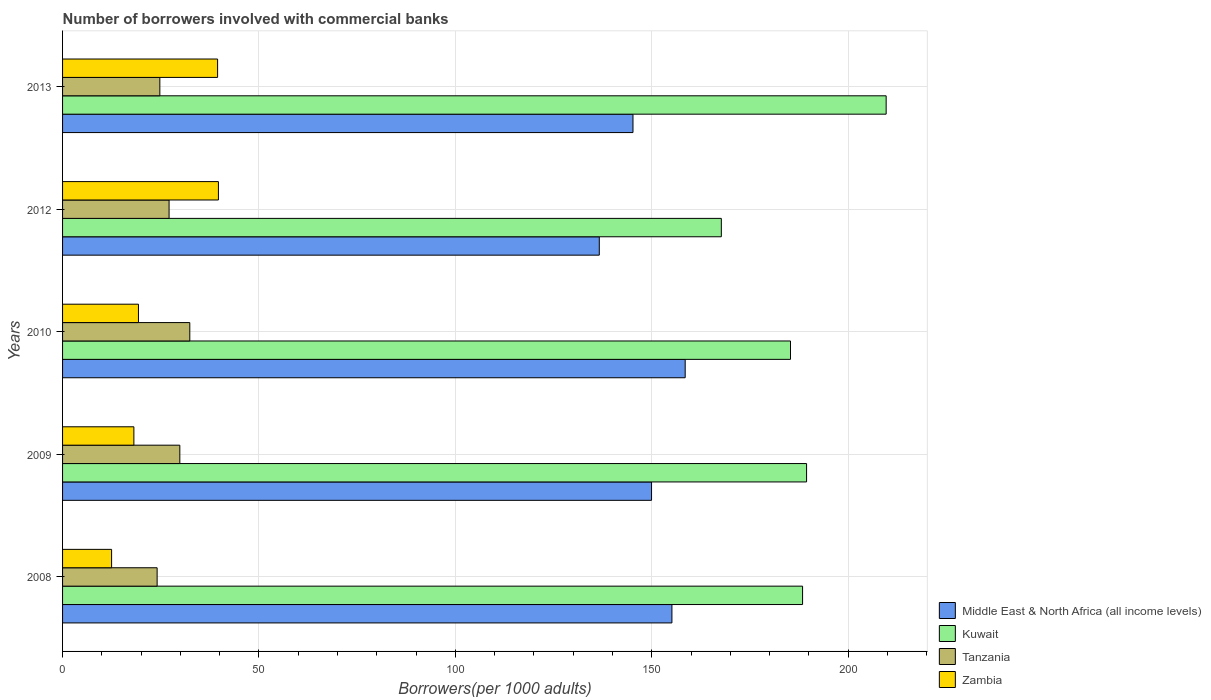How many different coloured bars are there?
Offer a terse response. 4. Are the number of bars per tick equal to the number of legend labels?
Your answer should be compact. Yes. How many bars are there on the 3rd tick from the top?
Offer a very short reply. 4. How many bars are there on the 3rd tick from the bottom?
Give a very brief answer. 4. What is the label of the 1st group of bars from the top?
Make the answer very short. 2013. What is the number of borrowers involved with commercial banks in Kuwait in 2008?
Give a very brief answer. 188.4. Across all years, what is the maximum number of borrowers involved with commercial banks in Middle East & North Africa (all income levels)?
Your response must be concise. 158.51. Across all years, what is the minimum number of borrowers involved with commercial banks in Kuwait?
Your answer should be very brief. 167.71. In which year was the number of borrowers involved with commercial banks in Zambia maximum?
Give a very brief answer. 2012. What is the total number of borrowers involved with commercial banks in Zambia in the graph?
Your response must be concise. 129.1. What is the difference between the number of borrowers involved with commercial banks in Tanzania in 2009 and that in 2012?
Your answer should be compact. 2.74. What is the difference between the number of borrowers involved with commercial banks in Middle East & North Africa (all income levels) in 2010 and the number of borrowers involved with commercial banks in Zambia in 2009?
Provide a short and direct response. 140.36. What is the average number of borrowers involved with commercial banks in Kuwait per year?
Give a very brief answer. 188.1. In the year 2009, what is the difference between the number of borrowers involved with commercial banks in Kuwait and number of borrowers involved with commercial banks in Zambia?
Your answer should be compact. 171.26. What is the ratio of the number of borrowers involved with commercial banks in Kuwait in 2009 to that in 2012?
Offer a very short reply. 1.13. Is the number of borrowers involved with commercial banks in Middle East & North Africa (all income levels) in 2010 less than that in 2012?
Your answer should be very brief. No. What is the difference between the highest and the second highest number of borrowers involved with commercial banks in Kuwait?
Provide a short and direct response. 20.26. What is the difference between the highest and the lowest number of borrowers involved with commercial banks in Middle East & North Africa (all income levels)?
Offer a very short reply. 21.87. What does the 1st bar from the top in 2009 represents?
Your answer should be compact. Zambia. What does the 1st bar from the bottom in 2008 represents?
Provide a short and direct response. Middle East & North Africa (all income levels). Is it the case that in every year, the sum of the number of borrowers involved with commercial banks in Tanzania and number of borrowers involved with commercial banks in Middle East & North Africa (all income levels) is greater than the number of borrowers involved with commercial banks in Zambia?
Keep it short and to the point. Yes. How many bars are there?
Offer a terse response. 20. What is the difference between two consecutive major ticks on the X-axis?
Provide a short and direct response. 50. How many legend labels are there?
Offer a terse response. 4. How are the legend labels stacked?
Offer a very short reply. Vertical. What is the title of the graph?
Offer a very short reply. Number of borrowers involved with commercial banks. Does "Somalia" appear as one of the legend labels in the graph?
Offer a terse response. No. What is the label or title of the X-axis?
Provide a short and direct response. Borrowers(per 1000 adults). What is the Borrowers(per 1000 adults) in Middle East & North Africa (all income levels) in 2008?
Offer a very short reply. 155.14. What is the Borrowers(per 1000 adults) in Kuwait in 2008?
Your response must be concise. 188.4. What is the Borrowers(per 1000 adults) in Tanzania in 2008?
Keep it short and to the point. 24.08. What is the Borrowers(per 1000 adults) in Zambia in 2008?
Offer a terse response. 12.48. What is the Borrowers(per 1000 adults) of Middle East & North Africa (all income levels) in 2009?
Your answer should be compact. 149.95. What is the Borrowers(per 1000 adults) in Kuwait in 2009?
Your answer should be very brief. 189.42. What is the Borrowers(per 1000 adults) of Tanzania in 2009?
Your answer should be compact. 29.86. What is the Borrowers(per 1000 adults) of Zambia in 2009?
Your response must be concise. 18.15. What is the Borrowers(per 1000 adults) of Middle East & North Africa (all income levels) in 2010?
Your response must be concise. 158.51. What is the Borrowers(per 1000 adults) in Kuwait in 2010?
Offer a very short reply. 185.32. What is the Borrowers(per 1000 adults) of Tanzania in 2010?
Ensure brevity in your answer.  32.39. What is the Borrowers(per 1000 adults) of Zambia in 2010?
Ensure brevity in your answer.  19.32. What is the Borrowers(per 1000 adults) in Middle East & North Africa (all income levels) in 2012?
Ensure brevity in your answer.  136.65. What is the Borrowers(per 1000 adults) in Kuwait in 2012?
Provide a short and direct response. 167.71. What is the Borrowers(per 1000 adults) of Tanzania in 2012?
Your answer should be compact. 27.12. What is the Borrowers(per 1000 adults) in Zambia in 2012?
Give a very brief answer. 39.68. What is the Borrowers(per 1000 adults) of Middle East & North Africa (all income levels) in 2013?
Your response must be concise. 145.22. What is the Borrowers(per 1000 adults) of Kuwait in 2013?
Ensure brevity in your answer.  209.68. What is the Borrowers(per 1000 adults) of Tanzania in 2013?
Your response must be concise. 24.77. What is the Borrowers(per 1000 adults) of Zambia in 2013?
Provide a short and direct response. 39.47. Across all years, what is the maximum Borrowers(per 1000 adults) in Middle East & North Africa (all income levels)?
Your answer should be very brief. 158.51. Across all years, what is the maximum Borrowers(per 1000 adults) in Kuwait?
Give a very brief answer. 209.68. Across all years, what is the maximum Borrowers(per 1000 adults) of Tanzania?
Ensure brevity in your answer.  32.39. Across all years, what is the maximum Borrowers(per 1000 adults) of Zambia?
Your answer should be compact. 39.68. Across all years, what is the minimum Borrowers(per 1000 adults) of Middle East & North Africa (all income levels)?
Provide a short and direct response. 136.65. Across all years, what is the minimum Borrowers(per 1000 adults) of Kuwait?
Make the answer very short. 167.71. Across all years, what is the minimum Borrowers(per 1000 adults) of Tanzania?
Offer a very short reply. 24.08. Across all years, what is the minimum Borrowers(per 1000 adults) in Zambia?
Your response must be concise. 12.48. What is the total Borrowers(per 1000 adults) of Middle East & North Africa (all income levels) in the graph?
Your response must be concise. 745.47. What is the total Borrowers(per 1000 adults) in Kuwait in the graph?
Give a very brief answer. 940.52. What is the total Borrowers(per 1000 adults) in Tanzania in the graph?
Keep it short and to the point. 138.2. What is the total Borrowers(per 1000 adults) of Zambia in the graph?
Your answer should be compact. 129.1. What is the difference between the Borrowers(per 1000 adults) of Middle East & North Africa (all income levels) in 2008 and that in 2009?
Keep it short and to the point. 5.19. What is the difference between the Borrowers(per 1000 adults) in Kuwait in 2008 and that in 2009?
Ensure brevity in your answer.  -1.02. What is the difference between the Borrowers(per 1000 adults) of Tanzania in 2008 and that in 2009?
Your answer should be compact. -5.78. What is the difference between the Borrowers(per 1000 adults) of Zambia in 2008 and that in 2009?
Give a very brief answer. -5.67. What is the difference between the Borrowers(per 1000 adults) of Middle East & North Africa (all income levels) in 2008 and that in 2010?
Your answer should be compact. -3.38. What is the difference between the Borrowers(per 1000 adults) of Kuwait in 2008 and that in 2010?
Make the answer very short. 3.08. What is the difference between the Borrowers(per 1000 adults) of Tanzania in 2008 and that in 2010?
Give a very brief answer. -8.32. What is the difference between the Borrowers(per 1000 adults) of Zambia in 2008 and that in 2010?
Provide a succinct answer. -6.84. What is the difference between the Borrowers(per 1000 adults) of Middle East & North Africa (all income levels) in 2008 and that in 2012?
Ensure brevity in your answer.  18.49. What is the difference between the Borrowers(per 1000 adults) in Kuwait in 2008 and that in 2012?
Provide a succinct answer. 20.68. What is the difference between the Borrowers(per 1000 adults) in Tanzania in 2008 and that in 2012?
Provide a short and direct response. -3.04. What is the difference between the Borrowers(per 1000 adults) of Zambia in 2008 and that in 2012?
Your answer should be very brief. -27.2. What is the difference between the Borrowers(per 1000 adults) of Middle East & North Africa (all income levels) in 2008 and that in 2013?
Your answer should be compact. 9.91. What is the difference between the Borrowers(per 1000 adults) in Kuwait in 2008 and that in 2013?
Provide a short and direct response. -21.28. What is the difference between the Borrowers(per 1000 adults) of Tanzania in 2008 and that in 2013?
Your answer should be compact. -0.69. What is the difference between the Borrowers(per 1000 adults) in Zambia in 2008 and that in 2013?
Your answer should be compact. -26.98. What is the difference between the Borrowers(per 1000 adults) of Middle East & North Africa (all income levels) in 2009 and that in 2010?
Ensure brevity in your answer.  -8.56. What is the difference between the Borrowers(per 1000 adults) of Kuwait in 2009 and that in 2010?
Your answer should be compact. 4.09. What is the difference between the Borrowers(per 1000 adults) of Tanzania in 2009 and that in 2010?
Provide a short and direct response. -2.54. What is the difference between the Borrowers(per 1000 adults) of Zambia in 2009 and that in 2010?
Your response must be concise. -1.17. What is the difference between the Borrowers(per 1000 adults) in Middle East & North Africa (all income levels) in 2009 and that in 2012?
Provide a succinct answer. 13.3. What is the difference between the Borrowers(per 1000 adults) of Kuwait in 2009 and that in 2012?
Offer a terse response. 21.7. What is the difference between the Borrowers(per 1000 adults) in Tanzania in 2009 and that in 2012?
Your answer should be compact. 2.74. What is the difference between the Borrowers(per 1000 adults) of Zambia in 2009 and that in 2012?
Make the answer very short. -21.52. What is the difference between the Borrowers(per 1000 adults) of Middle East & North Africa (all income levels) in 2009 and that in 2013?
Your answer should be compact. 4.73. What is the difference between the Borrowers(per 1000 adults) of Kuwait in 2009 and that in 2013?
Provide a succinct answer. -20.26. What is the difference between the Borrowers(per 1000 adults) in Tanzania in 2009 and that in 2013?
Make the answer very short. 5.09. What is the difference between the Borrowers(per 1000 adults) of Zambia in 2009 and that in 2013?
Make the answer very short. -21.31. What is the difference between the Borrowers(per 1000 adults) in Middle East & North Africa (all income levels) in 2010 and that in 2012?
Keep it short and to the point. 21.87. What is the difference between the Borrowers(per 1000 adults) of Kuwait in 2010 and that in 2012?
Your response must be concise. 17.61. What is the difference between the Borrowers(per 1000 adults) in Tanzania in 2010 and that in 2012?
Make the answer very short. 5.28. What is the difference between the Borrowers(per 1000 adults) in Zambia in 2010 and that in 2012?
Ensure brevity in your answer.  -20.36. What is the difference between the Borrowers(per 1000 adults) in Middle East & North Africa (all income levels) in 2010 and that in 2013?
Ensure brevity in your answer.  13.29. What is the difference between the Borrowers(per 1000 adults) of Kuwait in 2010 and that in 2013?
Ensure brevity in your answer.  -24.35. What is the difference between the Borrowers(per 1000 adults) in Tanzania in 2010 and that in 2013?
Offer a very short reply. 7.63. What is the difference between the Borrowers(per 1000 adults) of Zambia in 2010 and that in 2013?
Your answer should be very brief. -20.14. What is the difference between the Borrowers(per 1000 adults) of Middle East & North Africa (all income levels) in 2012 and that in 2013?
Make the answer very short. -8.58. What is the difference between the Borrowers(per 1000 adults) in Kuwait in 2012 and that in 2013?
Your answer should be compact. -41.96. What is the difference between the Borrowers(per 1000 adults) of Tanzania in 2012 and that in 2013?
Give a very brief answer. 2.35. What is the difference between the Borrowers(per 1000 adults) in Zambia in 2012 and that in 2013?
Your answer should be very brief. 0.21. What is the difference between the Borrowers(per 1000 adults) of Middle East & North Africa (all income levels) in 2008 and the Borrowers(per 1000 adults) of Kuwait in 2009?
Your response must be concise. -34.28. What is the difference between the Borrowers(per 1000 adults) in Middle East & North Africa (all income levels) in 2008 and the Borrowers(per 1000 adults) in Tanzania in 2009?
Ensure brevity in your answer.  125.28. What is the difference between the Borrowers(per 1000 adults) of Middle East & North Africa (all income levels) in 2008 and the Borrowers(per 1000 adults) of Zambia in 2009?
Keep it short and to the point. 136.98. What is the difference between the Borrowers(per 1000 adults) in Kuwait in 2008 and the Borrowers(per 1000 adults) in Tanzania in 2009?
Keep it short and to the point. 158.54. What is the difference between the Borrowers(per 1000 adults) of Kuwait in 2008 and the Borrowers(per 1000 adults) of Zambia in 2009?
Offer a terse response. 170.24. What is the difference between the Borrowers(per 1000 adults) in Tanzania in 2008 and the Borrowers(per 1000 adults) in Zambia in 2009?
Keep it short and to the point. 5.92. What is the difference between the Borrowers(per 1000 adults) in Middle East & North Africa (all income levels) in 2008 and the Borrowers(per 1000 adults) in Kuwait in 2010?
Provide a short and direct response. -30.19. What is the difference between the Borrowers(per 1000 adults) of Middle East & North Africa (all income levels) in 2008 and the Borrowers(per 1000 adults) of Tanzania in 2010?
Your response must be concise. 122.74. What is the difference between the Borrowers(per 1000 adults) of Middle East & North Africa (all income levels) in 2008 and the Borrowers(per 1000 adults) of Zambia in 2010?
Offer a terse response. 135.81. What is the difference between the Borrowers(per 1000 adults) of Kuwait in 2008 and the Borrowers(per 1000 adults) of Tanzania in 2010?
Provide a succinct answer. 156.01. What is the difference between the Borrowers(per 1000 adults) in Kuwait in 2008 and the Borrowers(per 1000 adults) in Zambia in 2010?
Your answer should be compact. 169.08. What is the difference between the Borrowers(per 1000 adults) of Tanzania in 2008 and the Borrowers(per 1000 adults) of Zambia in 2010?
Ensure brevity in your answer.  4.75. What is the difference between the Borrowers(per 1000 adults) of Middle East & North Africa (all income levels) in 2008 and the Borrowers(per 1000 adults) of Kuwait in 2012?
Offer a terse response. -12.58. What is the difference between the Borrowers(per 1000 adults) in Middle East & North Africa (all income levels) in 2008 and the Borrowers(per 1000 adults) in Tanzania in 2012?
Provide a succinct answer. 128.02. What is the difference between the Borrowers(per 1000 adults) of Middle East & North Africa (all income levels) in 2008 and the Borrowers(per 1000 adults) of Zambia in 2012?
Provide a short and direct response. 115.46. What is the difference between the Borrowers(per 1000 adults) of Kuwait in 2008 and the Borrowers(per 1000 adults) of Tanzania in 2012?
Your answer should be compact. 161.28. What is the difference between the Borrowers(per 1000 adults) of Kuwait in 2008 and the Borrowers(per 1000 adults) of Zambia in 2012?
Offer a very short reply. 148.72. What is the difference between the Borrowers(per 1000 adults) of Tanzania in 2008 and the Borrowers(per 1000 adults) of Zambia in 2012?
Ensure brevity in your answer.  -15.6. What is the difference between the Borrowers(per 1000 adults) in Middle East & North Africa (all income levels) in 2008 and the Borrowers(per 1000 adults) in Kuwait in 2013?
Make the answer very short. -54.54. What is the difference between the Borrowers(per 1000 adults) of Middle East & North Africa (all income levels) in 2008 and the Borrowers(per 1000 adults) of Tanzania in 2013?
Your answer should be very brief. 130.37. What is the difference between the Borrowers(per 1000 adults) of Middle East & North Africa (all income levels) in 2008 and the Borrowers(per 1000 adults) of Zambia in 2013?
Offer a terse response. 115.67. What is the difference between the Borrowers(per 1000 adults) in Kuwait in 2008 and the Borrowers(per 1000 adults) in Tanzania in 2013?
Offer a terse response. 163.63. What is the difference between the Borrowers(per 1000 adults) in Kuwait in 2008 and the Borrowers(per 1000 adults) in Zambia in 2013?
Your response must be concise. 148.93. What is the difference between the Borrowers(per 1000 adults) in Tanzania in 2008 and the Borrowers(per 1000 adults) in Zambia in 2013?
Your response must be concise. -15.39. What is the difference between the Borrowers(per 1000 adults) of Middle East & North Africa (all income levels) in 2009 and the Borrowers(per 1000 adults) of Kuwait in 2010?
Give a very brief answer. -35.37. What is the difference between the Borrowers(per 1000 adults) in Middle East & North Africa (all income levels) in 2009 and the Borrowers(per 1000 adults) in Tanzania in 2010?
Make the answer very short. 117.56. What is the difference between the Borrowers(per 1000 adults) in Middle East & North Africa (all income levels) in 2009 and the Borrowers(per 1000 adults) in Zambia in 2010?
Provide a short and direct response. 130.63. What is the difference between the Borrowers(per 1000 adults) of Kuwait in 2009 and the Borrowers(per 1000 adults) of Tanzania in 2010?
Your answer should be very brief. 157.02. What is the difference between the Borrowers(per 1000 adults) of Kuwait in 2009 and the Borrowers(per 1000 adults) of Zambia in 2010?
Keep it short and to the point. 170.09. What is the difference between the Borrowers(per 1000 adults) in Tanzania in 2009 and the Borrowers(per 1000 adults) in Zambia in 2010?
Offer a terse response. 10.53. What is the difference between the Borrowers(per 1000 adults) in Middle East & North Africa (all income levels) in 2009 and the Borrowers(per 1000 adults) in Kuwait in 2012?
Ensure brevity in your answer.  -17.76. What is the difference between the Borrowers(per 1000 adults) of Middle East & North Africa (all income levels) in 2009 and the Borrowers(per 1000 adults) of Tanzania in 2012?
Provide a succinct answer. 122.83. What is the difference between the Borrowers(per 1000 adults) of Middle East & North Africa (all income levels) in 2009 and the Borrowers(per 1000 adults) of Zambia in 2012?
Offer a very short reply. 110.27. What is the difference between the Borrowers(per 1000 adults) in Kuwait in 2009 and the Borrowers(per 1000 adults) in Tanzania in 2012?
Give a very brief answer. 162.3. What is the difference between the Borrowers(per 1000 adults) in Kuwait in 2009 and the Borrowers(per 1000 adults) in Zambia in 2012?
Offer a very short reply. 149.74. What is the difference between the Borrowers(per 1000 adults) in Tanzania in 2009 and the Borrowers(per 1000 adults) in Zambia in 2012?
Make the answer very short. -9.82. What is the difference between the Borrowers(per 1000 adults) in Middle East & North Africa (all income levels) in 2009 and the Borrowers(per 1000 adults) in Kuwait in 2013?
Provide a succinct answer. -59.73. What is the difference between the Borrowers(per 1000 adults) of Middle East & North Africa (all income levels) in 2009 and the Borrowers(per 1000 adults) of Tanzania in 2013?
Keep it short and to the point. 125.18. What is the difference between the Borrowers(per 1000 adults) of Middle East & North Africa (all income levels) in 2009 and the Borrowers(per 1000 adults) of Zambia in 2013?
Provide a succinct answer. 110.48. What is the difference between the Borrowers(per 1000 adults) in Kuwait in 2009 and the Borrowers(per 1000 adults) in Tanzania in 2013?
Ensure brevity in your answer.  164.65. What is the difference between the Borrowers(per 1000 adults) in Kuwait in 2009 and the Borrowers(per 1000 adults) in Zambia in 2013?
Give a very brief answer. 149.95. What is the difference between the Borrowers(per 1000 adults) of Tanzania in 2009 and the Borrowers(per 1000 adults) of Zambia in 2013?
Offer a very short reply. -9.61. What is the difference between the Borrowers(per 1000 adults) in Middle East & North Africa (all income levels) in 2010 and the Borrowers(per 1000 adults) in Kuwait in 2012?
Ensure brevity in your answer.  -9.2. What is the difference between the Borrowers(per 1000 adults) of Middle East & North Africa (all income levels) in 2010 and the Borrowers(per 1000 adults) of Tanzania in 2012?
Your answer should be very brief. 131.4. What is the difference between the Borrowers(per 1000 adults) of Middle East & North Africa (all income levels) in 2010 and the Borrowers(per 1000 adults) of Zambia in 2012?
Your response must be concise. 118.84. What is the difference between the Borrowers(per 1000 adults) in Kuwait in 2010 and the Borrowers(per 1000 adults) in Tanzania in 2012?
Provide a short and direct response. 158.21. What is the difference between the Borrowers(per 1000 adults) of Kuwait in 2010 and the Borrowers(per 1000 adults) of Zambia in 2012?
Keep it short and to the point. 145.64. What is the difference between the Borrowers(per 1000 adults) in Tanzania in 2010 and the Borrowers(per 1000 adults) in Zambia in 2012?
Give a very brief answer. -7.29. What is the difference between the Borrowers(per 1000 adults) of Middle East & North Africa (all income levels) in 2010 and the Borrowers(per 1000 adults) of Kuwait in 2013?
Your response must be concise. -51.16. What is the difference between the Borrowers(per 1000 adults) in Middle East & North Africa (all income levels) in 2010 and the Borrowers(per 1000 adults) in Tanzania in 2013?
Provide a succinct answer. 133.75. What is the difference between the Borrowers(per 1000 adults) of Middle East & North Africa (all income levels) in 2010 and the Borrowers(per 1000 adults) of Zambia in 2013?
Offer a terse response. 119.05. What is the difference between the Borrowers(per 1000 adults) in Kuwait in 2010 and the Borrowers(per 1000 adults) in Tanzania in 2013?
Your answer should be very brief. 160.56. What is the difference between the Borrowers(per 1000 adults) in Kuwait in 2010 and the Borrowers(per 1000 adults) in Zambia in 2013?
Provide a short and direct response. 145.85. What is the difference between the Borrowers(per 1000 adults) in Tanzania in 2010 and the Borrowers(per 1000 adults) in Zambia in 2013?
Offer a very short reply. -7.07. What is the difference between the Borrowers(per 1000 adults) in Middle East & North Africa (all income levels) in 2012 and the Borrowers(per 1000 adults) in Kuwait in 2013?
Your answer should be very brief. -73.03. What is the difference between the Borrowers(per 1000 adults) in Middle East & North Africa (all income levels) in 2012 and the Borrowers(per 1000 adults) in Tanzania in 2013?
Give a very brief answer. 111.88. What is the difference between the Borrowers(per 1000 adults) in Middle East & North Africa (all income levels) in 2012 and the Borrowers(per 1000 adults) in Zambia in 2013?
Your response must be concise. 97.18. What is the difference between the Borrowers(per 1000 adults) in Kuwait in 2012 and the Borrowers(per 1000 adults) in Tanzania in 2013?
Offer a terse response. 142.95. What is the difference between the Borrowers(per 1000 adults) of Kuwait in 2012 and the Borrowers(per 1000 adults) of Zambia in 2013?
Keep it short and to the point. 128.25. What is the difference between the Borrowers(per 1000 adults) of Tanzania in 2012 and the Borrowers(per 1000 adults) of Zambia in 2013?
Offer a very short reply. -12.35. What is the average Borrowers(per 1000 adults) of Middle East & North Africa (all income levels) per year?
Ensure brevity in your answer.  149.09. What is the average Borrowers(per 1000 adults) in Kuwait per year?
Offer a very short reply. 188.1. What is the average Borrowers(per 1000 adults) in Tanzania per year?
Provide a short and direct response. 27.64. What is the average Borrowers(per 1000 adults) in Zambia per year?
Your response must be concise. 25.82. In the year 2008, what is the difference between the Borrowers(per 1000 adults) in Middle East & North Africa (all income levels) and Borrowers(per 1000 adults) in Kuwait?
Offer a terse response. -33.26. In the year 2008, what is the difference between the Borrowers(per 1000 adults) of Middle East & North Africa (all income levels) and Borrowers(per 1000 adults) of Tanzania?
Offer a very short reply. 131.06. In the year 2008, what is the difference between the Borrowers(per 1000 adults) in Middle East & North Africa (all income levels) and Borrowers(per 1000 adults) in Zambia?
Offer a very short reply. 142.65. In the year 2008, what is the difference between the Borrowers(per 1000 adults) of Kuwait and Borrowers(per 1000 adults) of Tanzania?
Offer a terse response. 164.32. In the year 2008, what is the difference between the Borrowers(per 1000 adults) of Kuwait and Borrowers(per 1000 adults) of Zambia?
Give a very brief answer. 175.92. In the year 2008, what is the difference between the Borrowers(per 1000 adults) of Tanzania and Borrowers(per 1000 adults) of Zambia?
Make the answer very short. 11.59. In the year 2009, what is the difference between the Borrowers(per 1000 adults) of Middle East & North Africa (all income levels) and Borrowers(per 1000 adults) of Kuwait?
Your answer should be very brief. -39.47. In the year 2009, what is the difference between the Borrowers(per 1000 adults) of Middle East & North Africa (all income levels) and Borrowers(per 1000 adults) of Tanzania?
Offer a very short reply. 120.09. In the year 2009, what is the difference between the Borrowers(per 1000 adults) of Middle East & North Africa (all income levels) and Borrowers(per 1000 adults) of Zambia?
Provide a succinct answer. 131.8. In the year 2009, what is the difference between the Borrowers(per 1000 adults) of Kuwait and Borrowers(per 1000 adults) of Tanzania?
Give a very brief answer. 159.56. In the year 2009, what is the difference between the Borrowers(per 1000 adults) of Kuwait and Borrowers(per 1000 adults) of Zambia?
Provide a short and direct response. 171.26. In the year 2009, what is the difference between the Borrowers(per 1000 adults) of Tanzania and Borrowers(per 1000 adults) of Zambia?
Give a very brief answer. 11.7. In the year 2010, what is the difference between the Borrowers(per 1000 adults) in Middle East & North Africa (all income levels) and Borrowers(per 1000 adults) in Kuwait?
Give a very brief answer. -26.81. In the year 2010, what is the difference between the Borrowers(per 1000 adults) in Middle East & North Africa (all income levels) and Borrowers(per 1000 adults) in Tanzania?
Your answer should be compact. 126.12. In the year 2010, what is the difference between the Borrowers(per 1000 adults) of Middle East & North Africa (all income levels) and Borrowers(per 1000 adults) of Zambia?
Ensure brevity in your answer.  139.19. In the year 2010, what is the difference between the Borrowers(per 1000 adults) of Kuwait and Borrowers(per 1000 adults) of Tanzania?
Your answer should be compact. 152.93. In the year 2010, what is the difference between the Borrowers(per 1000 adults) in Kuwait and Borrowers(per 1000 adults) in Zambia?
Make the answer very short. 166. In the year 2010, what is the difference between the Borrowers(per 1000 adults) in Tanzania and Borrowers(per 1000 adults) in Zambia?
Offer a terse response. 13.07. In the year 2012, what is the difference between the Borrowers(per 1000 adults) of Middle East & North Africa (all income levels) and Borrowers(per 1000 adults) of Kuwait?
Make the answer very short. -31.07. In the year 2012, what is the difference between the Borrowers(per 1000 adults) of Middle East & North Africa (all income levels) and Borrowers(per 1000 adults) of Tanzania?
Keep it short and to the point. 109.53. In the year 2012, what is the difference between the Borrowers(per 1000 adults) of Middle East & North Africa (all income levels) and Borrowers(per 1000 adults) of Zambia?
Your response must be concise. 96.97. In the year 2012, what is the difference between the Borrowers(per 1000 adults) of Kuwait and Borrowers(per 1000 adults) of Tanzania?
Offer a very short reply. 140.6. In the year 2012, what is the difference between the Borrowers(per 1000 adults) in Kuwait and Borrowers(per 1000 adults) in Zambia?
Ensure brevity in your answer.  128.04. In the year 2012, what is the difference between the Borrowers(per 1000 adults) of Tanzania and Borrowers(per 1000 adults) of Zambia?
Your answer should be compact. -12.56. In the year 2013, what is the difference between the Borrowers(per 1000 adults) of Middle East & North Africa (all income levels) and Borrowers(per 1000 adults) of Kuwait?
Make the answer very short. -64.45. In the year 2013, what is the difference between the Borrowers(per 1000 adults) in Middle East & North Africa (all income levels) and Borrowers(per 1000 adults) in Tanzania?
Provide a succinct answer. 120.46. In the year 2013, what is the difference between the Borrowers(per 1000 adults) in Middle East & North Africa (all income levels) and Borrowers(per 1000 adults) in Zambia?
Make the answer very short. 105.76. In the year 2013, what is the difference between the Borrowers(per 1000 adults) of Kuwait and Borrowers(per 1000 adults) of Tanzania?
Keep it short and to the point. 184.91. In the year 2013, what is the difference between the Borrowers(per 1000 adults) of Kuwait and Borrowers(per 1000 adults) of Zambia?
Provide a short and direct response. 170.21. In the year 2013, what is the difference between the Borrowers(per 1000 adults) of Tanzania and Borrowers(per 1000 adults) of Zambia?
Make the answer very short. -14.7. What is the ratio of the Borrowers(per 1000 adults) of Middle East & North Africa (all income levels) in 2008 to that in 2009?
Your response must be concise. 1.03. What is the ratio of the Borrowers(per 1000 adults) of Kuwait in 2008 to that in 2009?
Provide a succinct answer. 0.99. What is the ratio of the Borrowers(per 1000 adults) of Tanzania in 2008 to that in 2009?
Provide a short and direct response. 0.81. What is the ratio of the Borrowers(per 1000 adults) of Zambia in 2008 to that in 2009?
Ensure brevity in your answer.  0.69. What is the ratio of the Borrowers(per 1000 adults) in Middle East & North Africa (all income levels) in 2008 to that in 2010?
Your answer should be compact. 0.98. What is the ratio of the Borrowers(per 1000 adults) of Kuwait in 2008 to that in 2010?
Offer a very short reply. 1.02. What is the ratio of the Borrowers(per 1000 adults) in Tanzania in 2008 to that in 2010?
Provide a short and direct response. 0.74. What is the ratio of the Borrowers(per 1000 adults) in Zambia in 2008 to that in 2010?
Your answer should be compact. 0.65. What is the ratio of the Borrowers(per 1000 adults) in Middle East & North Africa (all income levels) in 2008 to that in 2012?
Offer a very short reply. 1.14. What is the ratio of the Borrowers(per 1000 adults) in Kuwait in 2008 to that in 2012?
Offer a very short reply. 1.12. What is the ratio of the Borrowers(per 1000 adults) in Tanzania in 2008 to that in 2012?
Make the answer very short. 0.89. What is the ratio of the Borrowers(per 1000 adults) in Zambia in 2008 to that in 2012?
Your answer should be very brief. 0.31. What is the ratio of the Borrowers(per 1000 adults) of Middle East & North Africa (all income levels) in 2008 to that in 2013?
Your answer should be very brief. 1.07. What is the ratio of the Borrowers(per 1000 adults) in Kuwait in 2008 to that in 2013?
Offer a very short reply. 0.9. What is the ratio of the Borrowers(per 1000 adults) of Tanzania in 2008 to that in 2013?
Provide a short and direct response. 0.97. What is the ratio of the Borrowers(per 1000 adults) of Zambia in 2008 to that in 2013?
Your answer should be compact. 0.32. What is the ratio of the Borrowers(per 1000 adults) in Middle East & North Africa (all income levels) in 2009 to that in 2010?
Keep it short and to the point. 0.95. What is the ratio of the Borrowers(per 1000 adults) of Kuwait in 2009 to that in 2010?
Ensure brevity in your answer.  1.02. What is the ratio of the Borrowers(per 1000 adults) of Tanzania in 2009 to that in 2010?
Offer a terse response. 0.92. What is the ratio of the Borrowers(per 1000 adults) in Zambia in 2009 to that in 2010?
Give a very brief answer. 0.94. What is the ratio of the Borrowers(per 1000 adults) in Middle East & North Africa (all income levels) in 2009 to that in 2012?
Your answer should be compact. 1.1. What is the ratio of the Borrowers(per 1000 adults) of Kuwait in 2009 to that in 2012?
Make the answer very short. 1.13. What is the ratio of the Borrowers(per 1000 adults) of Tanzania in 2009 to that in 2012?
Provide a succinct answer. 1.1. What is the ratio of the Borrowers(per 1000 adults) of Zambia in 2009 to that in 2012?
Keep it short and to the point. 0.46. What is the ratio of the Borrowers(per 1000 adults) in Middle East & North Africa (all income levels) in 2009 to that in 2013?
Give a very brief answer. 1.03. What is the ratio of the Borrowers(per 1000 adults) of Kuwait in 2009 to that in 2013?
Offer a terse response. 0.9. What is the ratio of the Borrowers(per 1000 adults) in Tanzania in 2009 to that in 2013?
Provide a succinct answer. 1.21. What is the ratio of the Borrowers(per 1000 adults) of Zambia in 2009 to that in 2013?
Your response must be concise. 0.46. What is the ratio of the Borrowers(per 1000 adults) of Middle East & North Africa (all income levels) in 2010 to that in 2012?
Your answer should be very brief. 1.16. What is the ratio of the Borrowers(per 1000 adults) of Kuwait in 2010 to that in 2012?
Keep it short and to the point. 1.1. What is the ratio of the Borrowers(per 1000 adults) of Tanzania in 2010 to that in 2012?
Offer a terse response. 1.19. What is the ratio of the Borrowers(per 1000 adults) in Zambia in 2010 to that in 2012?
Your response must be concise. 0.49. What is the ratio of the Borrowers(per 1000 adults) in Middle East & North Africa (all income levels) in 2010 to that in 2013?
Your answer should be compact. 1.09. What is the ratio of the Borrowers(per 1000 adults) in Kuwait in 2010 to that in 2013?
Give a very brief answer. 0.88. What is the ratio of the Borrowers(per 1000 adults) of Tanzania in 2010 to that in 2013?
Keep it short and to the point. 1.31. What is the ratio of the Borrowers(per 1000 adults) in Zambia in 2010 to that in 2013?
Offer a terse response. 0.49. What is the ratio of the Borrowers(per 1000 adults) in Middle East & North Africa (all income levels) in 2012 to that in 2013?
Provide a short and direct response. 0.94. What is the ratio of the Borrowers(per 1000 adults) in Kuwait in 2012 to that in 2013?
Your answer should be very brief. 0.8. What is the ratio of the Borrowers(per 1000 adults) in Tanzania in 2012 to that in 2013?
Your answer should be compact. 1.09. What is the difference between the highest and the second highest Borrowers(per 1000 adults) of Middle East & North Africa (all income levels)?
Provide a succinct answer. 3.38. What is the difference between the highest and the second highest Borrowers(per 1000 adults) in Kuwait?
Provide a short and direct response. 20.26. What is the difference between the highest and the second highest Borrowers(per 1000 adults) in Tanzania?
Provide a short and direct response. 2.54. What is the difference between the highest and the second highest Borrowers(per 1000 adults) in Zambia?
Your response must be concise. 0.21. What is the difference between the highest and the lowest Borrowers(per 1000 adults) of Middle East & North Africa (all income levels)?
Your answer should be very brief. 21.87. What is the difference between the highest and the lowest Borrowers(per 1000 adults) in Kuwait?
Make the answer very short. 41.96. What is the difference between the highest and the lowest Borrowers(per 1000 adults) of Tanzania?
Provide a succinct answer. 8.32. What is the difference between the highest and the lowest Borrowers(per 1000 adults) of Zambia?
Make the answer very short. 27.2. 